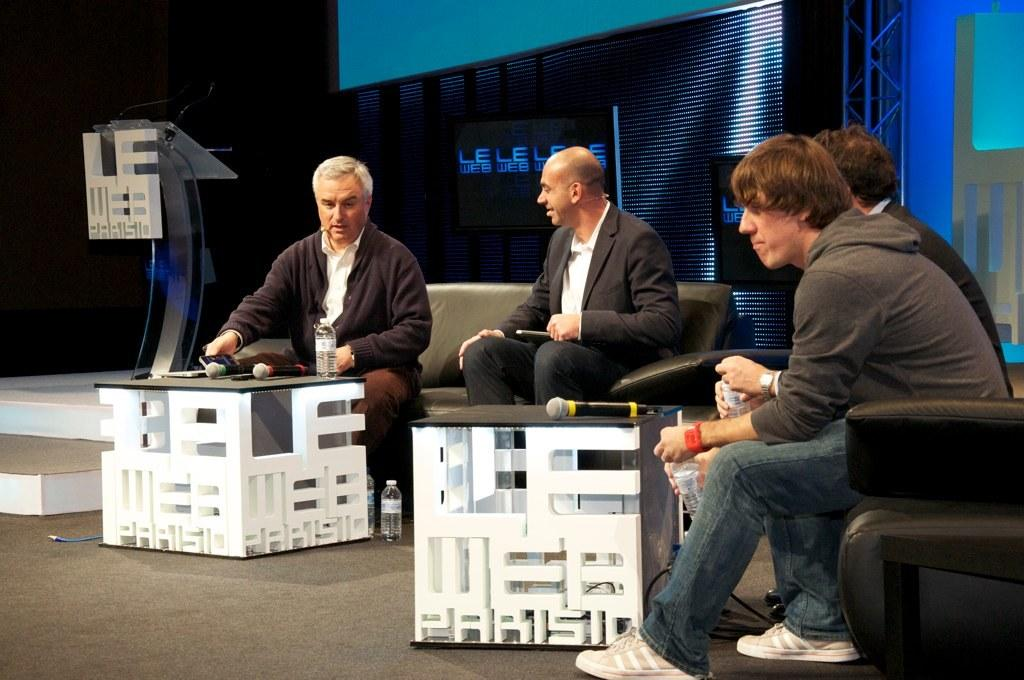Provide a one-sentence caption for the provided image. 4 men sitting on chairs and couches talking, the text on the bottom says Parisio. 